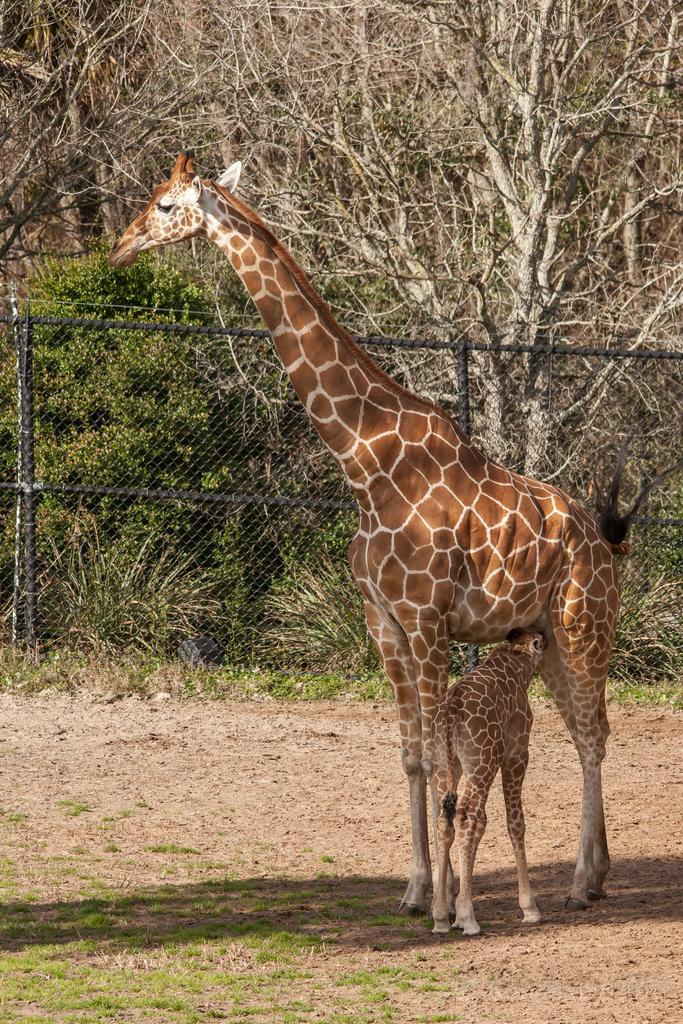Can you describe this image briefly? In this image we can see a giraffe on the ground. We can also see some grass, a metal fence and a group of trees. 